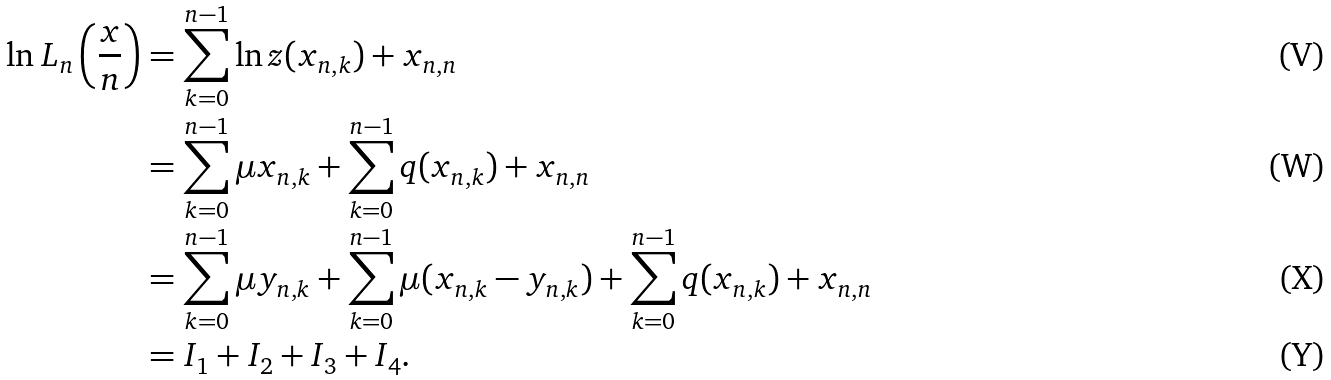<formula> <loc_0><loc_0><loc_500><loc_500>\ln L _ { n } \left ( \frac { x } { n } \right ) & = \sum _ { k = 0 } ^ { n - 1 } \ln z ( x _ { n , k } ) + x _ { n , n } \\ & = \sum _ { k = 0 } ^ { n - 1 } \mu x _ { n , k } + \sum _ { k = 0 } ^ { n - 1 } q ( x _ { n , k } ) + x _ { n , n } \\ & = \sum _ { k = 0 } ^ { n - 1 } \mu y _ { n , k } + \sum _ { k = 0 } ^ { n - 1 } \mu ( x _ { n , k } - y _ { n , k } ) + \sum _ { k = 0 } ^ { n - 1 } q ( x _ { n , k } ) + x _ { n , n } \\ & = I _ { 1 } + I _ { 2 } + I _ { 3 } + I _ { 4 } .</formula> 